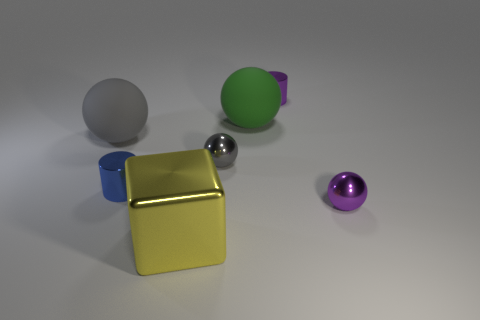There is a object in front of the purple metallic sphere; is it the same size as the large gray rubber object?
Give a very brief answer. Yes. There is another cylinder that is the same size as the blue metal cylinder; what is its color?
Ensure brevity in your answer.  Purple. There is a green ball; what number of big rubber things are right of it?
Make the answer very short. 0. Are there any spheres?
Make the answer very short. Yes. What is the size of the metallic cylinder that is on the left side of the small shiny sphere behind the tiny blue thing that is on the left side of the purple metallic cylinder?
Your response must be concise. Small. How many other objects are the same size as the yellow metallic object?
Your response must be concise. 2. How big is the gray sphere that is on the left side of the big yellow metal object?
Make the answer very short. Large. Is there anything else that is the same color as the metallic cube?
Provide a short and direct response. No. Are the tiny ball that is right of the green object and the tiny blue object made of the same material?
Your answer should be very brief. Yes. What number of cylinders are on the left side of the tiny gray metal object and behind the big green rubber thing?
Provide a succinct answer. 0. 